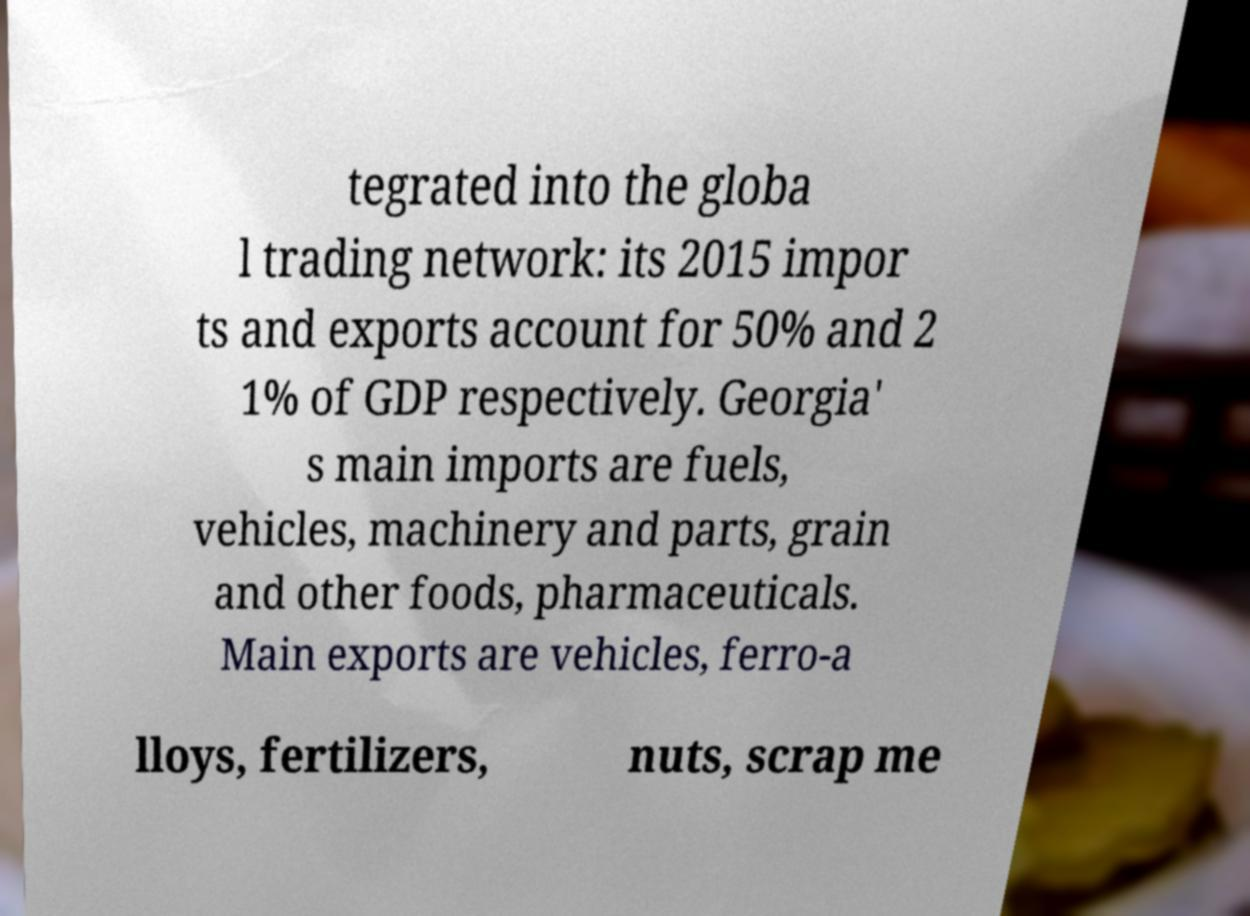Can you accurately transcribe the text from the provided image for me? tegrated into the globa l trading network: its 2015 impor ts and exports account for 50% and 2 1% of GDP respectively. Georgia' s main imports are fuels, vehicles, machinery and parts, grain and other foods, pharmaceuticals. Main exports are vehicles, ferro-a lloys, fertilizers, nuts, scrap me 